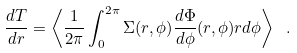<formula> <loc_0><loc_0><loc_500><loc_500>\frac { d T } { d r } = \left \langle \frac { 1 } { 2 \pi } \int _ { 0 } ^ { 2 \pi } \Sigma ( r , \phi ) \frac { d \Phi } { d \phi } ( r , \phi ) r d \phi \right \rangle \ .</formula> 